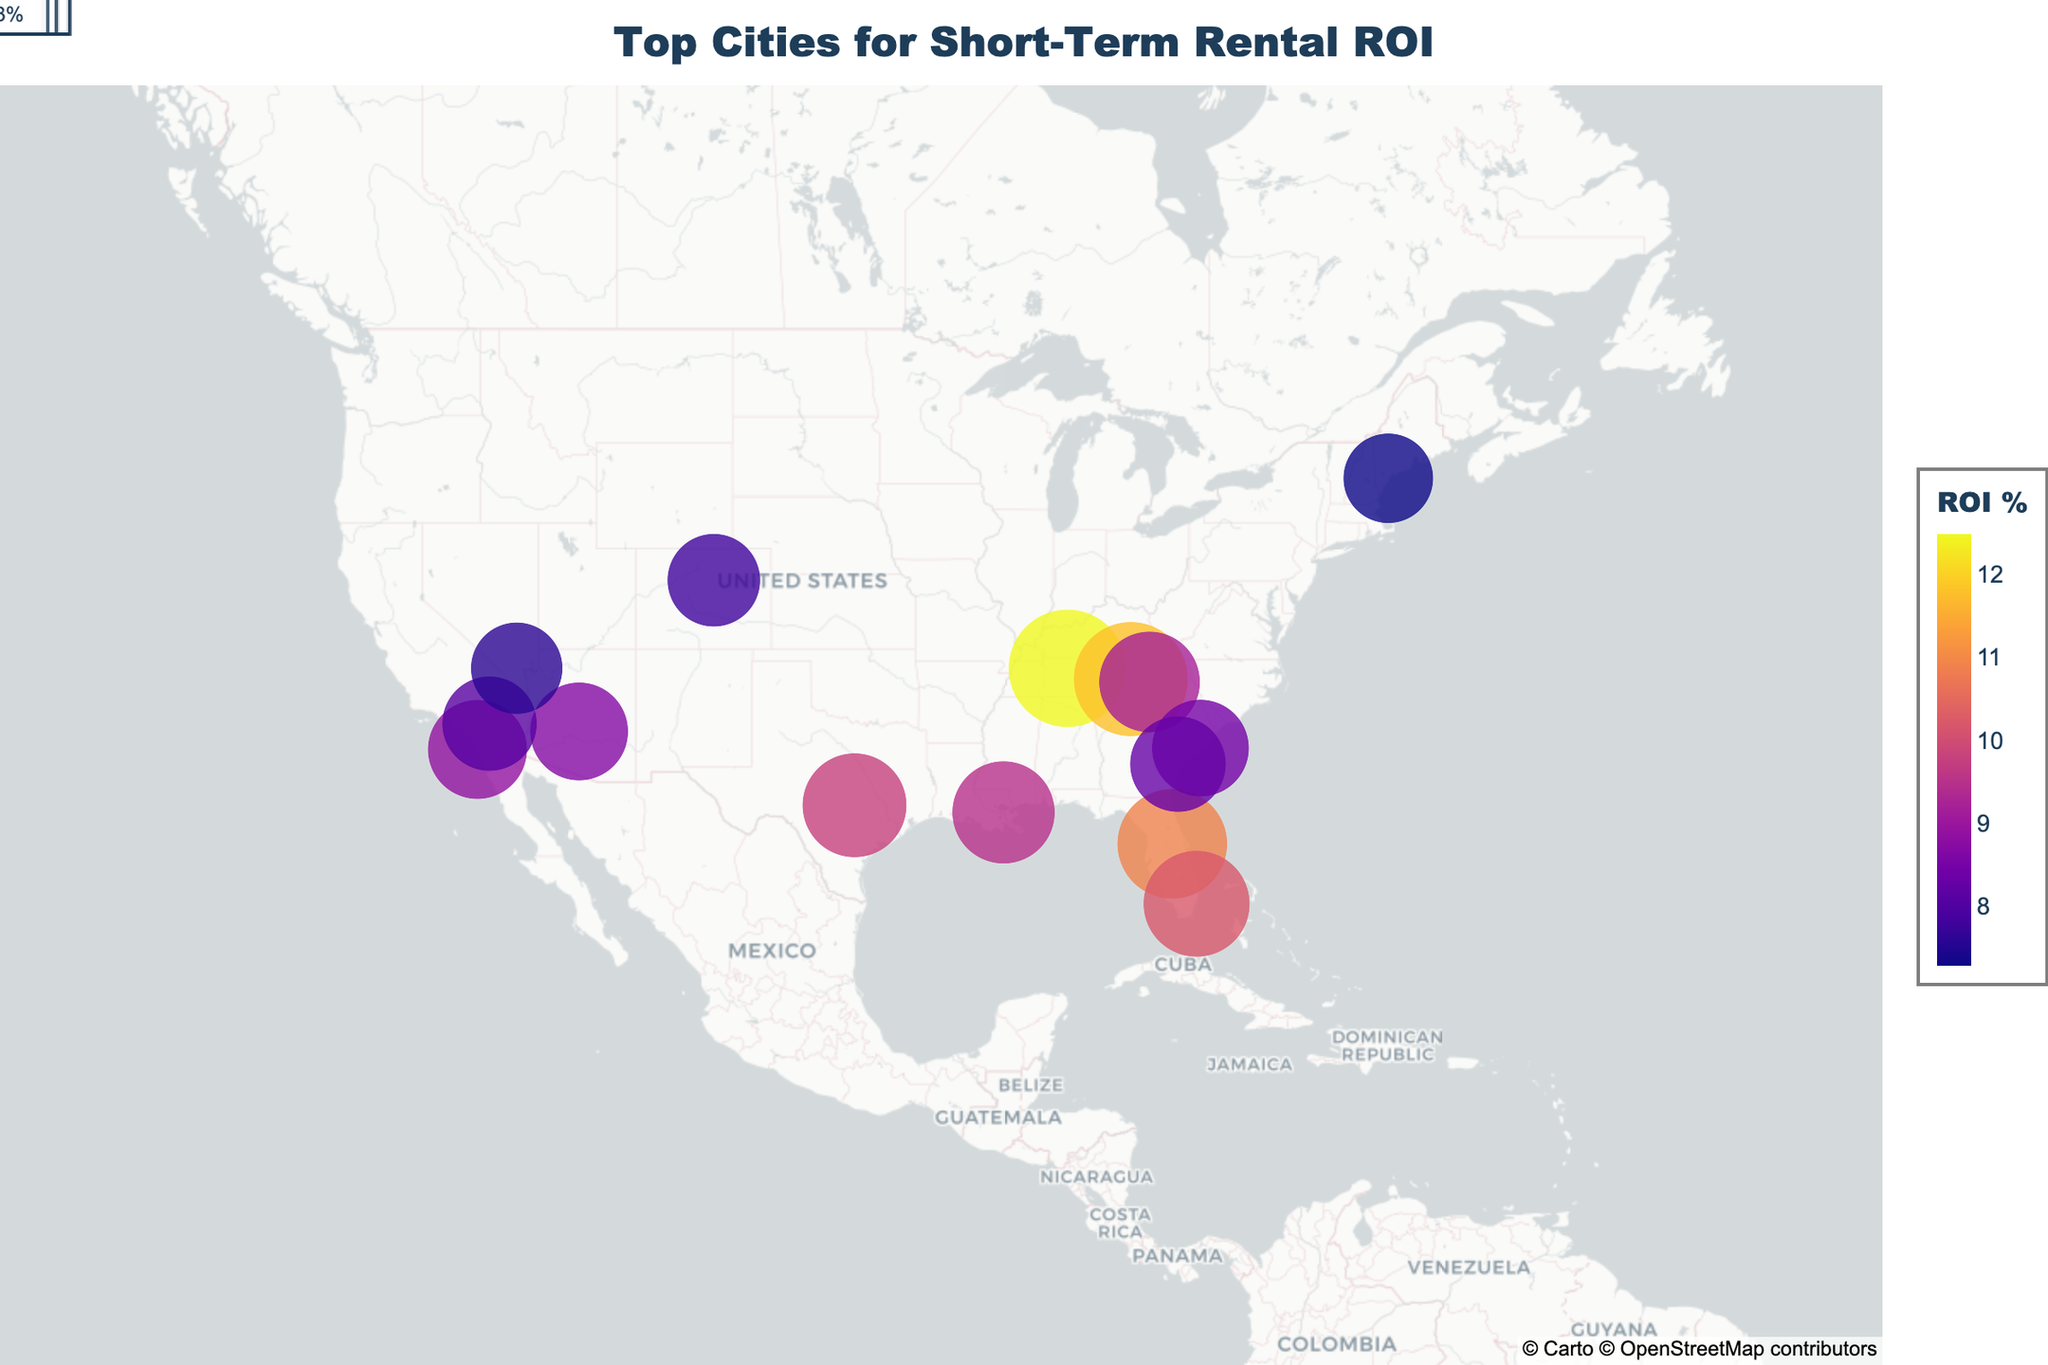What is the title of the map? The title is usually prominent and located at the top of the map. In this case, the title text is "Top Cities for Short-Term Rental ROI".
Answer: Top Cities for Short-Term Rental ROI Which city has the highest Return on Investment (ROI) percentage? The city with the highest ROI percentage typically has the largest and most colorful marker. In this map, Nashville, Tennessee, has the highest ROI percentage of 12.5.
Answer: Nashville, Tennessee How many locations have an ROI percentage higher than 10%? To determine this, identify the cities with an ROI percentage greater than 10%: Nashville, Gatlinburg, Orlando, and Miami Beach. There are four such locations.
Answer: 4 What are the top two states with the highest average ROI percentage? Calculate the average ROI for cities within each state and compare. Tennessee (average of Nashville and Gatlinburg: 12.5% and 11.8%) and Florida (average of Orlando and Miami Beach: 10.9% and 10.2%) have the highest averages. Tennessee average = (12.5+11.8)/2 = 12.15%, Florida average = (10.9+10.2)/2 = 10.55%.
Answer: Tennessee, Florida Which city is represented by a marker located at approximately 39.74 latitude and -104.99 longitude? Check the coordinates provided in the dataset and match them with the latitude and longitude on the map. Denver, Colorado, matches these coordinates.
Answer: Denver, Colorado What is the rank of Austin, Texas, in terms of ROI percentage among all the cities? List all cities and their ROI percentages, then rank them. Austin, Texas, with an ROI of 9.8%, is fifth in the ranking. Sorted ROIs: 12.5 (Nashville), 11.8 (Gatlinburg), 10.9 (Orlando), 10.2 (Miami Beach), 9.8 (Austin).
Answer: 5th Which state has the lowest average ROI based on the cities listed? Calculate the average ROI for each state and identify the lowest. Maine has only one city, Portland, with an ROI of 7.3%, which is the lowest.
Answer: Maine Compare the ROI percentage of San Diego, California, with Charleston, South Carolina. Which one is higher? Identify the ROI percentages for San Diego (8.9%) and Charleston (8.5%) and compare. San Diego has a higher ROI than Charleston.
Answer: San Diego What is the ROI percentage for the city located at approximately 32.08 latitude and -81.09 longitude? Find the city on the map corresponding to these coordinates, which is Savannah, Georgia, with an ROI of 8.3%.
Answer: 8.3% Of the cities with an ROI percentage between 8% and 9%, which one is the westernmost? Locate the cities with ROI percentages in the specified range and determine which one has the furthest west longitude. San Diego, California, at -117.1611 longitude, is the westernmost.
Answer: San Diego, California 